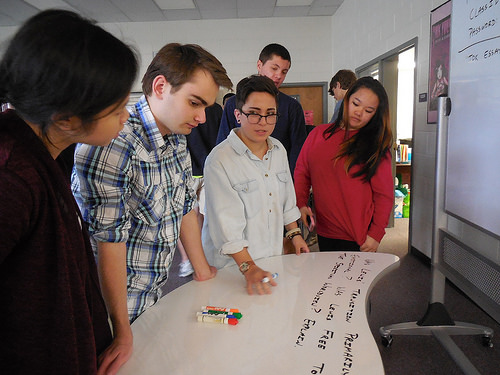<image>
Can you confirm if the glasses is on the man? No. The glasses is not positioned on the man. They may be near each other, but the glasses is not supported by or resting on top of the man. 